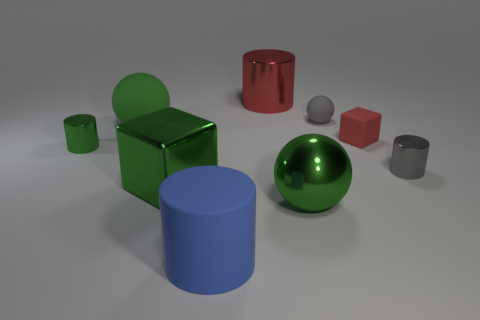There is a cylinder that is the same color as the large block; what material is it?
Your answer should be very brief. Metal. There is a sphere that is left of the big red thing; does it have the same size as the object that is left of the big green matte object?
Your answer should be compact. No. What color is the other large thing that is the same shape as the big red metallic object?
Offer a very short reply. Blue. Is there any other thing that is the same shape as the tiny green shiny object?
Your answer should be very brief. Yes. Are there more metallic blocks that are left of the small gray rubber sphere than small gray balls on the left side of the green matte sphere?
Offer a very short reply. Yes. There is a metal thing behind the small cylinder that is on the left side of the tiny cylinder that is right of the red cylinder; what size is it?
Provide a short and direct response. Large. Is the material of the big green cube the same as the big green ball in front of the green matte object?
Offer a terse response. Yes. Does the blue matte thing have the same shape as the tiny gray metal object?
Make the answer very short. Yes. How many other objects are there of the same material as the red cylinder?
Provide a succinct answer. 4. What number of large blue objects are the same shape as the red metal object?
Offer a very short reply. 1. 